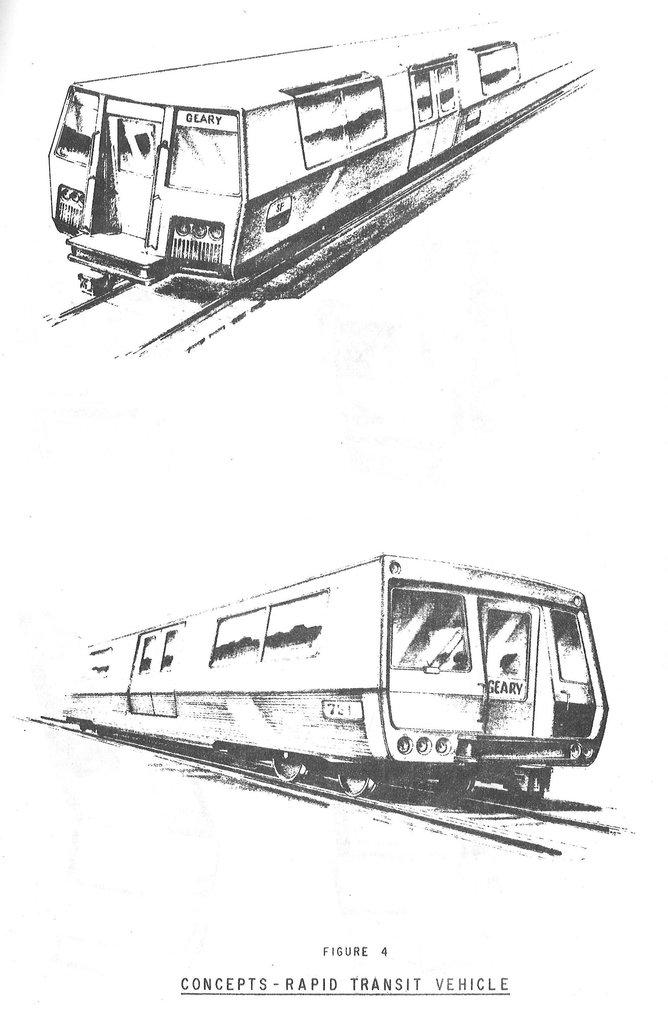What is depicted in the two drawings in the image? There are two drawings of a train in the image. What else can be seen at the bottom of the image? There is text at the bottom of the image. What type of yard is visible in the image? There is no yard present in the image; it features two drawings of a train and text at the bottom. Is there a scarf being worn by the train in the image? There is no train or person wearing a scarf in the image; it features two drawings of a train and text at the bottom. 